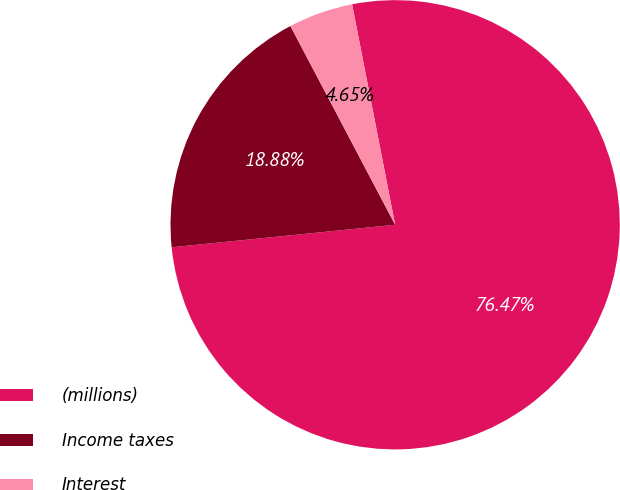Convert chart to OTSL. <chart><loc_0><loc_0><loc_500><loc_500><pie_chart><fcel>(millions)<fcel>Income taxes<fcel>Interest<nl><fcel>76.47%<fcel>18.88%<fcel>4.65%<nl></chart> 